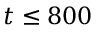<formula> <loc_0><loc_0><loc_500><loc_500>t \leq 8 0 0</formula> 